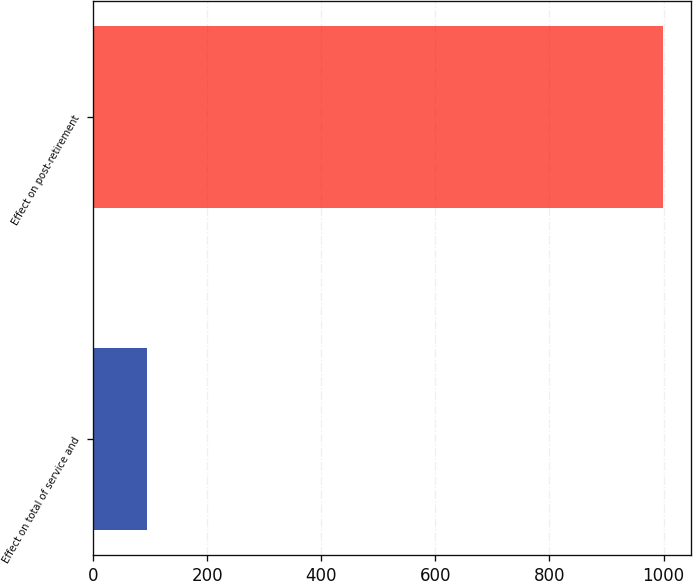Convert chart to OTSL. <chart><loc_0><loc_0><loc_500><loc_500><bar_chart><fcel>Effect on total of service and<fcel>Effect on post-retirement<nl><fcel>94<fcel>999<nl></chart> 